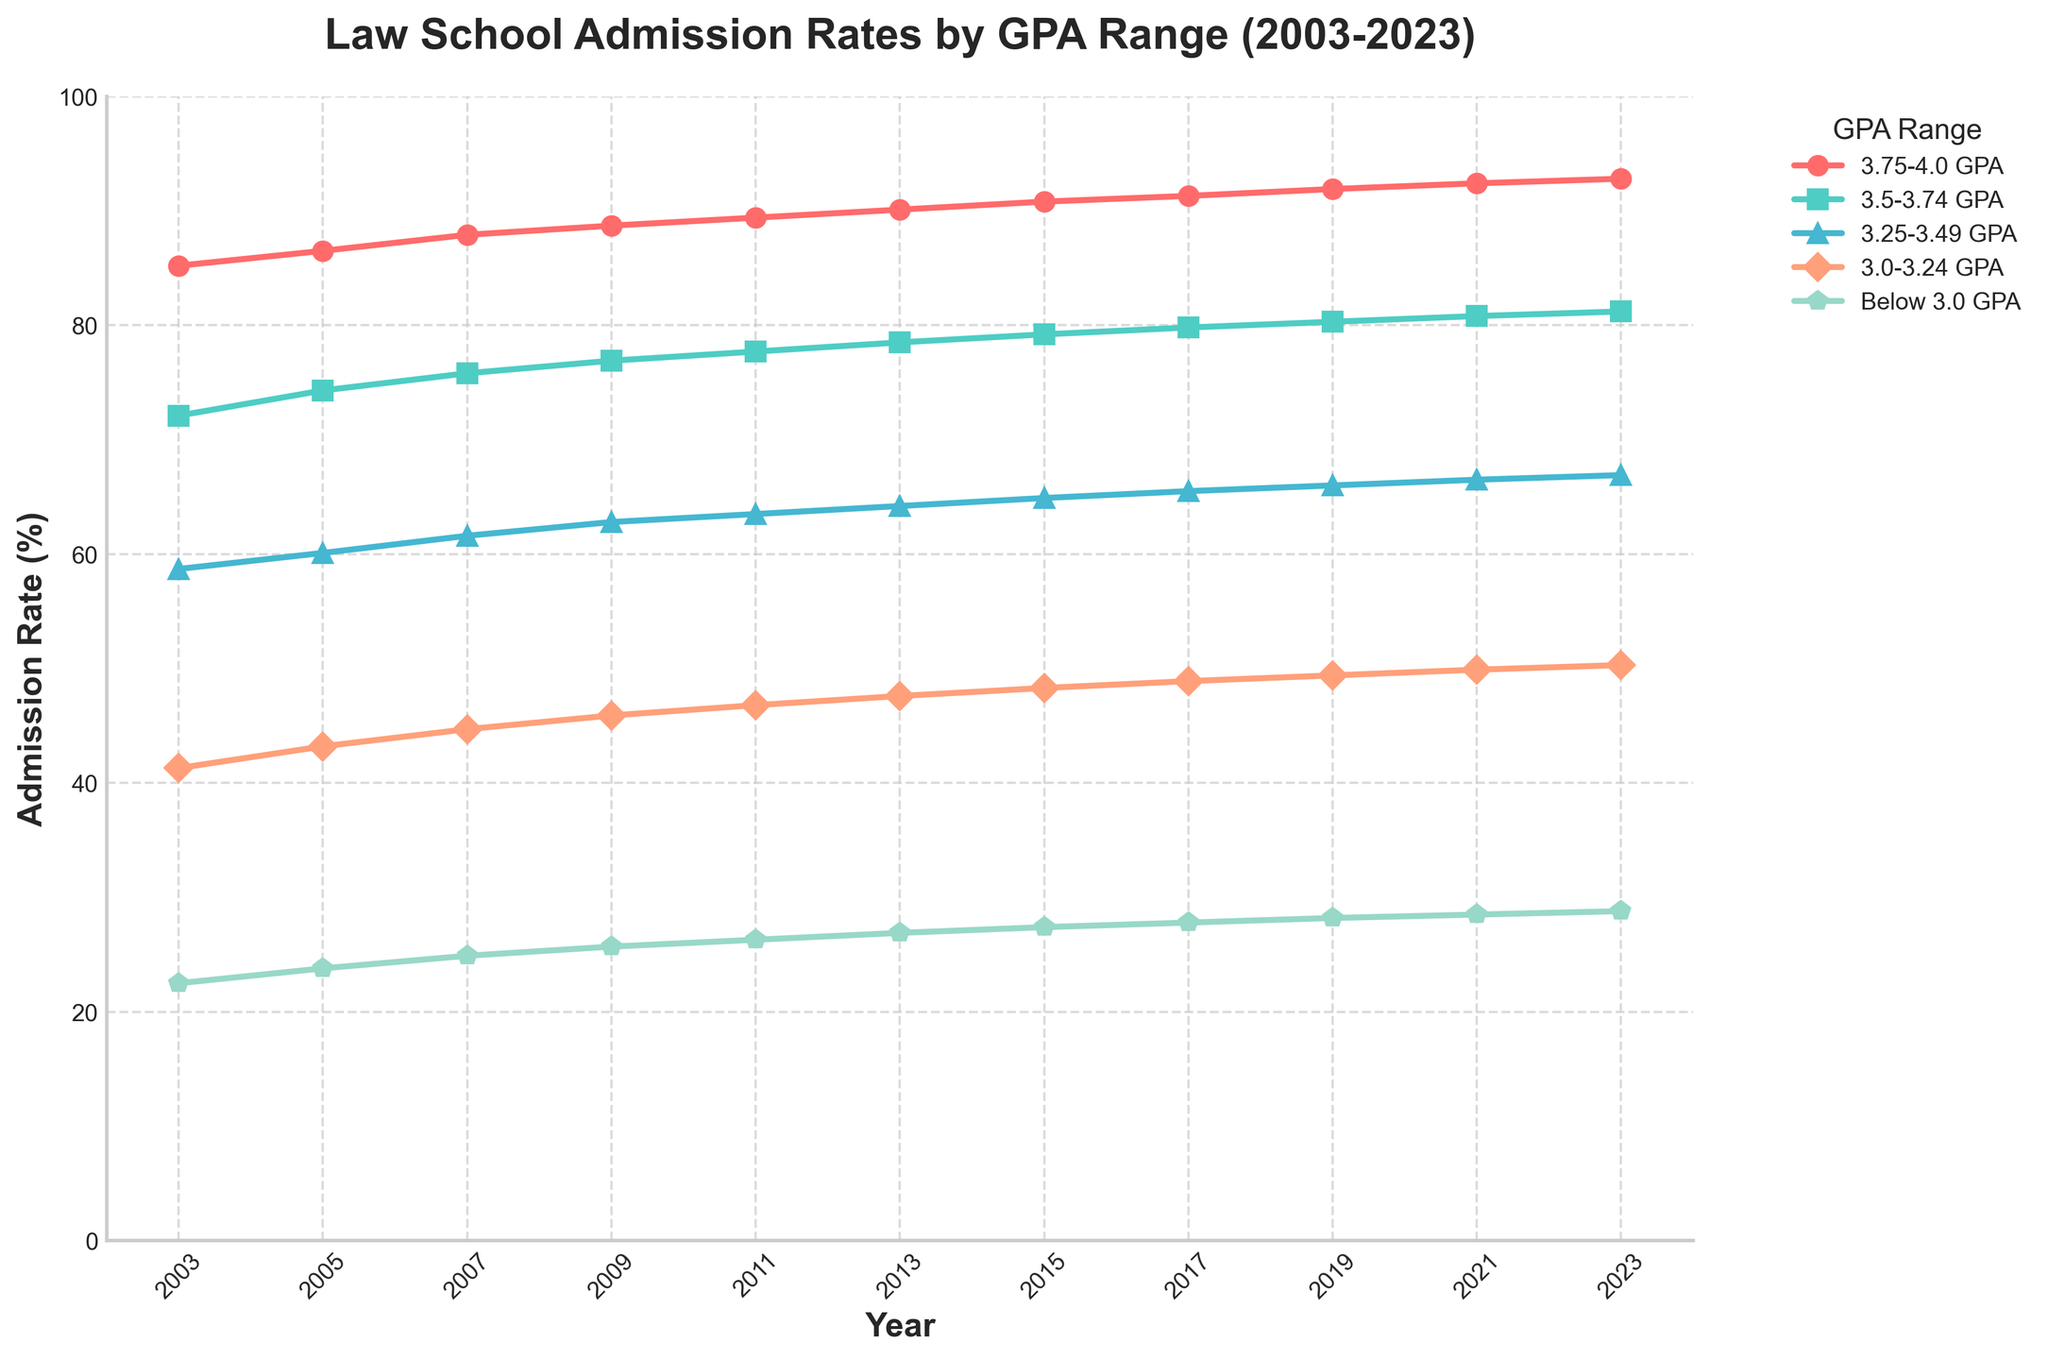What's the average admission rate for the "3.5-3.74 GPA" range over the displayed years? First, sum up all the admission rates for the "3.5-3.74 GPA" range from 2003 to 2023: (72.1 + 74.3 + 75.8 + 76.9 + 77.7 + 78.5 + 79.2 + 79.8 + 80.3 + 80.8 + 81.2). The sum is 876.6. Then, divide this sum by the number of years, which is 11. So, 876.6 / 11 = 79.69
Answer: 79.69 Which GPA range saw the largest increase in admission rates from 2003 to 2023? To find this, subtract the 2003 admission rate from the 2023 admission rate for each GPA range. The increments are: "3.75-4.0 GPA" = 92.8 - 85.2 = 7.6, "3.5-3.74 GPA" = 81.2 - 72.1 = 9.1, "3.25-3.49 GPA" = 66.9 - 58.7 = 8.2, "3.0-3.24 GPA" = 50.3 - 41.3 = 9.0, "Below 3.0 GPA" = 28.8 - 22.5 = 6.3. The largest increase is for the "3.5-3.74 GPA" range with an increase of 9.1 percentage points.
Answer: 3.5-3.74 GPA In which year did the "Below 3.0 GPA" group have an admission rate close to 25%? By visually inspecting the "Below 3.0 GPA" line, it intersects close to 25% around the years 2009 and 2011.
Answer: 2009 How did the admission rates for the "3.75-4.0 GPA" range change over the years, and which segment shows the most significant trend? The "3.75-4.0 GPA" range has a line consistently moving upward from 85.2% in 2003 to 92.8% in 2023, showing a steady increase. The most significant trend is the steady yearly increase without any declines.
Answer: Consistent increase Compare the admission rate trends between the "3.0-3.24 GPA" and "3.25-3.49 GPA" ranges from 2003 to 2023. The "3.0-3.24 GPA" range increased from 41.3% to 50.3%, a 9.0 percentage point rise. The "3.25-3.49 GPA" range increased from 58.7% to 66.9%, an 8.2 percentage point rise. Both show an upward trend, but the "3.0-3.24 GPA" range has a slightly larger increase.
Answer: 3.0-3.24 GPA increased more What's the combined admission rate of the "3.25-3.49 GPA" and "3.5-3.74 GPA" ranges in 2023? Add the admission rates of the "3.25-3.49 GPA" (66.9) and "3.5-3.74 GPA" (81.2) ranges for the year 2023: 66.9 + 81.2 = 148.1
Answer: 148.1 Which GPA range consistently had the lowest admission rate, and what was the trend for this range? The "Below 3.0 GPA" range consistently had the lowest admission rate each year. The trend shows a gradual but steady increase from 22.5% in 2003 to 28.8% in 2023.
Answer: Below 3.0 GPA Compare the year-to-year changes between 2011 and 2013 for the "3.0-3.24 GPA" and "Below 3.0 GPA" ranges. For the "3.0-3.24 GPA" range, the change from 2011 to 2013 is 47.6 - 46.8 = 0.8 percentage points. For the "Below 3.0 GPA" range, the change from 2011 to 2013 is 26.9 - 26.3 = 0.6 percentage points.
Answer: 3.0-3.24 GPA range increased more 